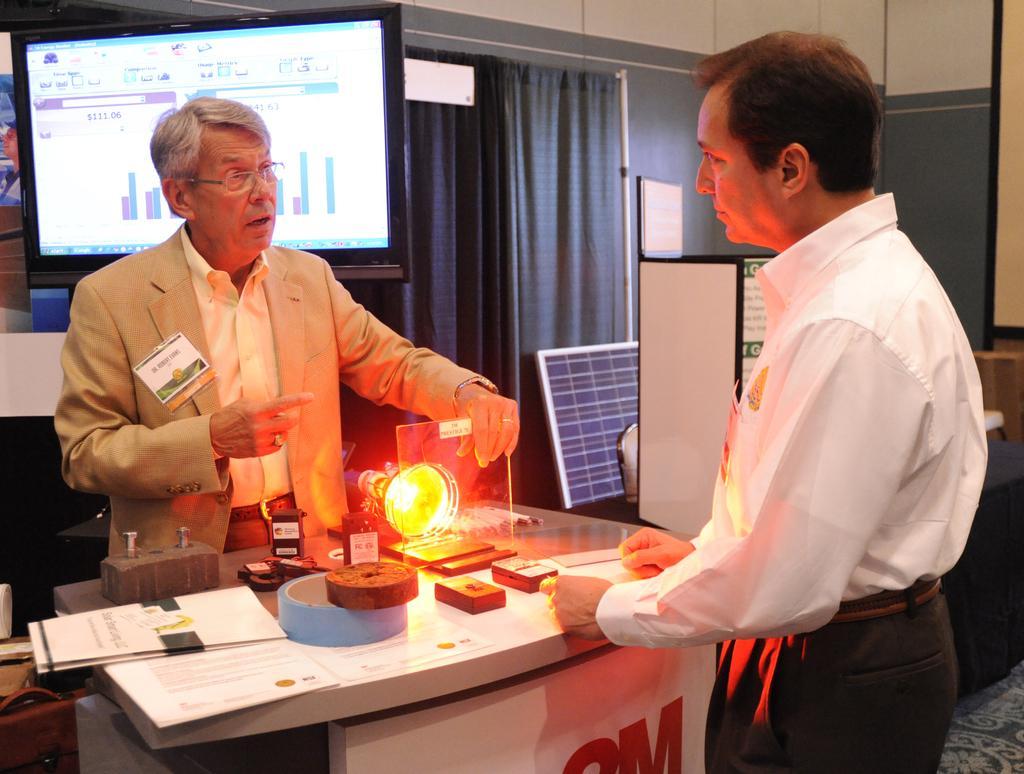In one or two sentences, can you explain what this image depicts? As we can see in the image there are curtains, wall, screen, two people standing over here and a table. On table there is light, papers and here there is a banner. 